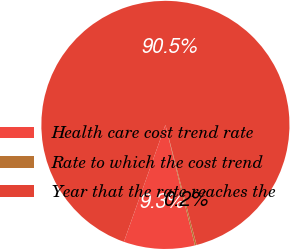Convert chart to OTSL. <chart><loc_0><loc_0><loc_500><loc_500><pie_chart><fcel>Health care cost trend rate<fcel>Rate to which the cost trend<fcel>Year that the rate reaches the<nl><fcel>9.25%<fcel>0.22%<fcel>90.52%<nl></chart> 